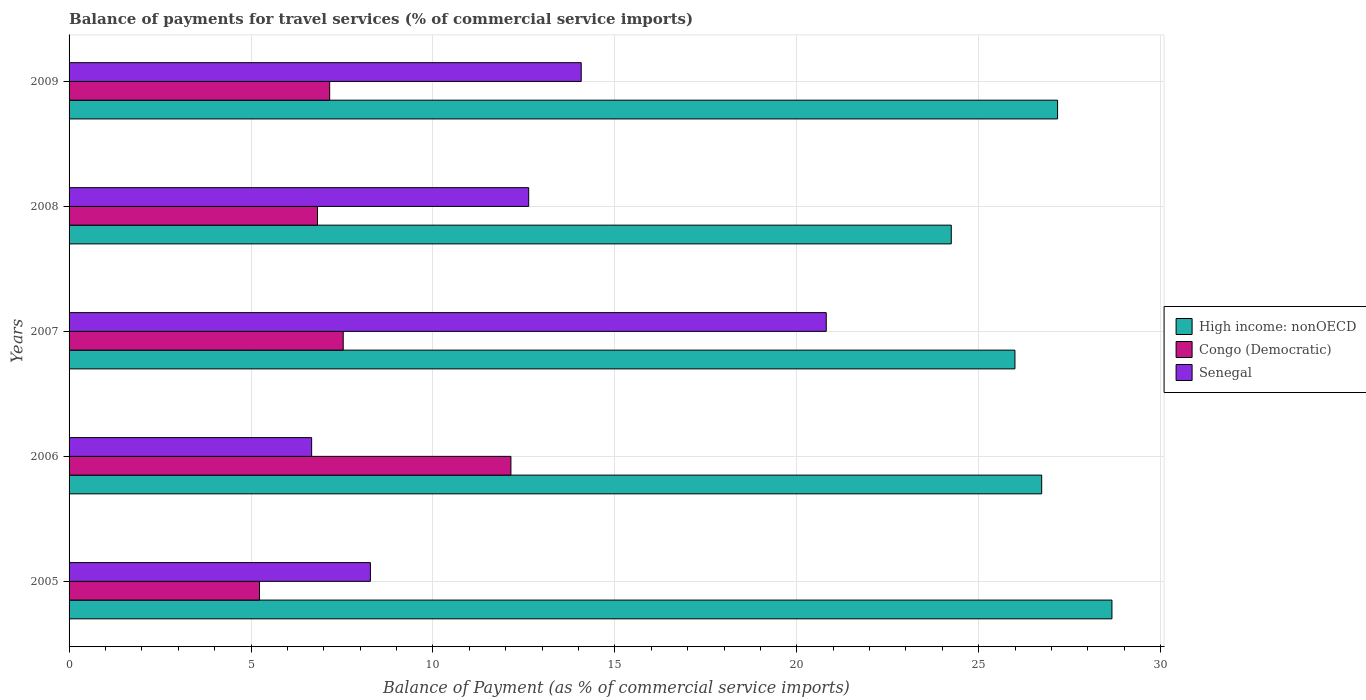How many groups of bars are there?
Your answer should be compact. 5. Are the number of bars per tick equal to the number of legend labels?
Give a very brief answer. Yes. Are the number of bars on each tick of the Y-axis equal?
Give a very brief answer. Yes. How many bars are there on the 2nd tick from the bottom?
Keep it short and to the point. 3. What is the balance of payments for travel services in High income: nonOECD in 2006?
Keep it short and to the point. 26.73. Across all years, what is the maximum balance of payments for travel services in High income: nonOECD?
Provide a short and direct response. 28.66. Across all years, what is the minimum balance of payments for travel services in High income: nonOECD?
Your response must be concise. 24.24. What is the total balance of payments for travel services in High income: nonOECD in the graph?
Provide a succinct answer. 132.8. What is the difference between the balance of payments for travel services in Congo (Democratic) in 2005 and that in 2008?
Provide a succinct answer. -1.59. What is the difference between the balance of payments for travel services in Senegal in 2005 and the balance of payments for travel services in High income: nonOECD in 2009?
Provide a short and direct response. -18.89. What is the average balance of payments for travel services in Senegal per year?
Make the answer very short. 12.49. In the year 2007, what is the difference between the balance of payments for travel services in Senegal and balance of payments for travel services in High income: nonOECD?
Offer a very short reply. -5.19. What is the ratio of the balance of payments for travel services in High income: nonOECD in 2007 to that in 2008?
Make the answer very short. 1.07. Is the balance of payments for travel services in Congo (Democratic) in 2006 less than that in 2009?
Provide a short and direct response. No. Is the difference between the balance of payments for travel services in Senegal in 2005 and 2009 greater than the difference between the balance of payments for travel services in High income: nonOECD in 2005 and 2009?
Your answer should be very brief. No. What is the difference between the highest and the second highest balance of payments for travel services in Senegal?
Provide a succinct answer. 6.73. What is the difference between the highest and the lowest balance of payments for travel services in High income: nonOECD?
Give a very brief answer. 4.42. In how many years, is the balance of payments for travel services in Congo (Democratic) greater than the average balance of payments for travel services in Congo (Democratic) taken over all years?
Provide a short and direct response. 1. Is the sum of the balance of payments for travel services in Senegal in 2006 and 2009 greater than the maximum balance of payments for travel services in Congo (Democratic) across all years?
Offer a very short reply. Yes. What does the 2nd bar from the top in 2007 represents?
Make the answer very short. Congo (Democratic). What does the 2nd bar from the bottom in 2006 represents?
Offer a terse response. Congo (Democratic). Is it the case that in every year, the sum of the balance of payments for travel services in High income: nonOECD and balance of payments for travel services in Congo (Democratic) is greater than the balance of payments for travel services in Senegal?
Provide a succinct answer. Yes. How many bars are there?
Make the answer very short. 15. Are all the bars in the graph horizontal?
Offer a terse response. Yes. How many years are there in the graph?
Give a very brief answer. 5. What is the difference between two consecutive major ticks on the X-axis?
Your answer should be compact. 5. Does the graph contain any zero values?
Your answer should be very brief. No. Does the graph contain grids?
Make the answer very short. Yes. What is the title of the graph?
Offer a very short reply. Balance of payments for travel services (% of commercial service imports). What is the label or title of the X-axis?
Provide a short and direct response. Balance of Payment (as % of commercial service imports). What is the Balance of Payment (as % of commercial service imports) of High income: nonOECD in 2005?
Keep it short and to the point. 28.66. What is the Balance of Payment (as % of commercial service imports) in Congo (Democratic) in 2005?
Your response must be concise. 5.23. What is the Balance of Payment (as % of commercial service imports) of Senegal in 2005?
Provide a succinct answer. 8.28. What is the Balance of Payment (as % of commercial service imports) of High income: nonOECD in 2006?
Your answer should be compact. 26.73. What is the Balance of Payment (as % of commercial service imports) in Congo (Democratic) in 2006?
Keep it short and to the point. 12.14. What is the Balance of Payment (as % of commercial service imports) in Senegal in 2006?
Offer a very short reply. 6.67. What is the Balance of Payment (as % of commercial service imports) in High income: nonOECD in 2007?
Ensure brevity in your answer.  25.99. What is the Balance of Payment (as % of commercial service imports) in Congo (Democratic) in 2007?
Provide a short and direct response. 7.53. What is the Balance of Payment (as % of commercial service imports) of Senegal in 2007?
Your response must be concise. 20.81. What is the Balance of Payment (as % of commercial service imports) of High income: nonOECD in 2008?
Keep it short and to the point. 24.24. What is the Balance of Payment (as % of commercial service imports) in Congo (Democratic) in 2008?
Offer a very short reply. 6.83. What is the Balance of Payment (as % of commercial service imports) of Senegal in 2008?
Provide a succinct answer. 12.63. What is the Balance of Payment (as % of commercial service imports) in High income: nonOECD in 2009?
Your response must be concise. 27.17. What is the Balance of Payment (as % of commercial service imports) in Congo (Democratic) in 2009?
Your response must be concise. 7.16. What is the Balance of Payment (as % of commercial service imports) of Senegal in 2009?
Provide a succinct answer. 14.07. Across all years, what is the maximum Balance of Payment (as % of commercial service imports) of High income: nonOECD?
Your answer should be very brief. 28.66. Across all years, what is the maximum Balance of Payment (as % of commercial service imports) of Congo (Democratic)?
Make the answer very short. 12.14. Across all years, what is the maximum Balance of Payment (as % of commercial service imports) in Senegal?
Offer a terse response. 20.81. Across all years, what is the minimum Balance of Payment (as % of commercial service imports) of High income: nonOECD?
Make the answer very short. 24.24. Across all years, what is the minimum Balance of Payment (as % of commercial service imports) in Congo (Democratic)?
Make the answer very short. 5.23. Across all years, what is the minimum Balance of Payment (as % of commercial service imports) of Senegal?
Provide a short and direct response. 6.67. What is the total Balance of Payment (as % of commercial service imports) in High income: nonOECD in the graph?
Offer a very short reply. 132.8. What is the total Balance of Payment (as % of commercial service imports) in Congo (Democratic) in the graph?
Make the answer very short. 38.9. What is the total Balance of Payment (as % of commercial service imports) in Senegal in the graph?
Your answer should be very brief. 62.46. What is the difference between the Balance of Payment (as % of commercial service imports) in High income: nonOECD in 2005 and that in 2006?
Offer a terse response. 1.93. What is the difference between the Balance of Payment (as % of commercial service imports) in Congo (Democratic) in 2005 and that in 2006?
Make the answer very short. -6.91. What is the difference between the Balance of Payment (as % of commercial service imports) of Senegal in 2005 and that in 2006?
Provide a short and direct response. 1.62. What is the difference between the Balance of Payment (as % of commercial service imports) of High income: nonOECD in 2005 and that in 2007?
Give a very brief answer. 2.67. What is the difference between the Balance of Payment (as % of commercial service imports) of Congo (Democratic) in 2005 and that in 2007?
Your answer should be very brief. -2.3. What is the difference between the Balance of Payment (as % of commercial service imports) in Senegal in 2005 and that in 2007?
Make the answer very short. -12.53. What is the difference between the Balance of Payment (as % of commercial service imports) of High income: nonOECD in 2005 and that in 2008?
Offer a terse response. 4.42. What is the difference between the Balance of Payment (as % of commercial service imports) of Congo (Democratic) in 2005 and that in 2008?
Make the answer very short. -1.59. What is the difference between the Balance of Payment (as % of commercial service imports) of Senegal in 2005 and that in 2008?
Offer a terse response. -4.35. What is the difference between the Balance of Payment (as % of commercial service imports) of High income: nonOECD in 2005 and that in 2009?
Give a very brief answer. 1.49. What is the difference between the Balance of Payment (as % of commercial service imports) in Congo (Democratic) in 2005 and that in 2009?
Offer a terse response. -1.93. What is the difference between the Balance of Payment (as % of commercial service imports) in Senegal in 2005 and that in 2009?
Your response must be concise. -5.79. What is the difference between the Balance of Payment (as % of commercial service imports) in High income: nonOECD in 2006 and that in 2007?
Keep it short and to the point. 0.74. What is the difference between the Balance of Payment (as % of commercial service imports) of Congo (Democratic) in 2006 and that in 2007?
Keep it short and to the point. 4.61. What is the difference between the Balance of Payment (as % of commercial service imports) of Senegal in 2006 and that in 2007?
Your answer should be compact. -14.14. What is the difference between the Balance of Payment (as % of commercial service imports) of High income: nonOECD in 2006 and that in 2008?
Offer a very short reply. 2.48. What is the difference between the Balance of Payment (as % of commercial service imports) of Congo (Democratic) in 2006 and that in 2008?
Offer a very short reply. 5.32. What is the difference between the Balance of Payment (as % of commercial service imports) of Senegal in 2006 and that in 2008?
Your answer should be compact. -5.97. What is the difference between the Balance of Payment (as % of commercial service imports) in High income: nonOECD in 2006 and that in 2009?
Offer a very short reply. -0.44. What is the difference between the Balance of Payment (as % of commercial service imports) of Congo (Democratic) in 2006 and that in 2009?
Give a very brief answer. 4.98. What is the difference between the Balance of Payment (as % of commercial service imports) in Senegal in 2006 and that in 2009?
Make the answer very short. -7.41. What is the difference between the Balance of Payment (as % of commercial service imports) in High income: nonOECD in 2007 and that in 2008?
Ensure brevity in your answer.  1.75. What is the difference between the Balance of Payment (as % of commercial service imports) in Congo (Democratic) in 2007 and that in 2008?
Your answer should be very brief. 0.71. What is the difference between the Balance of Payment (as % of commercial service imports) in Senegal in 2007 and that in 2008?
Give a very brief answer. 8.18. What is the difference between the Balance of Payment (as % of commercial service imports) in High income: nonOECD in 2007 and that in 2009?
Provide a succinct answer. -1.17. What is the difference between the Balance of Payment (as % of commercial service imports) of Congo (Democratic) in 2007 and that in 2009?
Keep it short and to the point. 0.37. What is the difference between the Balance of Payment (as % of commercial service imports) of Senegal in 2007 and that in 2009?
Offer a very short reply. 6.73. What is the difference between the Balance of Payment (as % of commercial service imports) in High income: nonOECD in 2008 and that in 2009?
Your response must be concise. -2.92. What is the difference between the Balance of Payment (as % of commercial service imports) in Congo (Democratic) in 2008 and that in 2009?
Give a very brief answer. -0.34. What is the difference between the Balance of Payment (as % of commercial service imports) in Senegal in 2008 and that in 2009?
Provide a succinct answer. -1.44. What is the difference between the Balance of Payment (as % of commercial service imports) in High income: nonOECD in 2005 and the Balance of Payment (as % of commercial service imports) in Congo (Democratic) in 2006?
Ensure brevity in your answer.  16.52. What is the difference between the Balance of Payment (as % of commercial service imports) of High income: nonOECD in 2005 and the Balance of Payment (as % of commercial service imports) of Senegal in 2006?
Offer a terse response. 21.99. What is the difference between the Balance of Payment (as % of commercial service imports) in Congo (Democratic) in 2005 and the Balance of Payment (as % of commercial service imports) in Senegal in 2006?
Ensure brevity in your answer.  -1.43. What is the difference between the Balance of Payment (as % of commercial service imports) in High income: nonOECD in 2005 and the Balance of Payment (as % of commercial service imports) in Congo (Democratic) in 2007?
Ensure brevity in your answer.  21.13. What is the difference between the Balance of Payment (as % of commercial service imports) of High income: nonOECD in 2005 and the Balance of Payment (as % of commercial service imports) of Senegal in 2007?
Make the answer very short. 7.85. What is the difference between the Balance of Payment (as % of commercial service imports) of Congo (Democratic) in 2005 and the Balance of Payment (as % of commercial service imports) of Senegal in 2007?
Make the answer very short. -15.58. What is the difference between the Balance of Payment (as % of commercial service imports) of High income: nonOECD in 2005 and the Balance of Payment (as % of commercial service imports) of Congo (Democratic) in 2008?
Keep it short and to the point. 21.83. What is the difference between the Balance of Payment (as % of commercial service imports) in High income: nonOECD in 2005 and the Balance of Payment (as % of commercial service imports) in Senegal in 2008?
Offer a terse response. 16.03. What is the difference between the Balance of Payment (as % of commercial service imports) of Congo (Democratic) in 2005 and the Balance of Payment (as % of commercial service imports) of Senegal in 2008?
Your response must be concise. -7.4. What is the difference between the Balance of Payment (as % of commercial service imports) of High income: nonOECD in 2005 and the Balance of Payment (as % of commercial service imports) of Congo (Democratic) in 2009?
Ensure brevity in your answer.  21.5. What is the difference between the Balance of Payment (as % of commercial service imports) of High income: nonOECD in 2005 and the Balance of Payment (as % of commercial service imports) of Senegal in 2009?
Offer a very short reply. 14.59. What is the difference between the Balance of Payment (as % of commercial service imports) of Congo (Democratic) in 2005 and the Balance of Payment (as % of commercial service imports) of Senegal in 2009?
Provide a short and direct response. -8.84. What is the difference between the Balance of Payment (as % of commercial service imports) in High income: nonOECD in 2006 and the Balance of Payment (as % of commercial service imports) in Congo (Democratic) in 2007?
Your response must be concise. 19.2. What is the difference between the Balance of Payment (as % of commercial service imports) of High income: nonOECD in 2006 and the Balance of Payment (as % of commercial service imports) of Senegal in 2007?
Offer a very short reply. 5.92. What is the difference between the Balance of Payment (as % of commercial service imports) in Congo (Democratic) in 2006 and the Balance of Payment (as % of commercial service imports) in Senegal in 2007?
Keep it short and to the point. -8.67. What is the difference between the Balance of Payment (as % of commercial service imports) in High income: nonOECD in 2006 and the Balance of Payment (as % of commercial service imports) in Congo (Democratic) in 2008?
Make the answer very short. 19.9. What is the difference between the Balance of Payment (as % of commercial service imports) in High income: nonOECD in 2006 and the Balance of Payment (as % of commercial service imports) in Senegal in 2008?
Your response must be concise. 14.1. What is the difference between the Balance of Payment (as % of commercial service imports) in Congo (Democratic) in 2006 and the Balance of Payment (as % of commercial service imports) in Senegal in 2008?
Your response must be concise. -0.49. What is the difference between the Balance of Payment (as % of commercial service imports) of High income: nonOECD in 2006 and the Balance of Payment (as % of commercial service imports) of Congo (Democratic) in 2009?
Provide a succinct answer. 19.57. What is the difference between the Balance of Payment (as % of commercial service imports) in High income: nonOECD in 2006 and the Balance of Payment (as % of commercial service imports) in Senegal in 2009?
Offer a terse response. 12.65. What is the difference between the Balance of Payment (as % of commercial service imports) of Congo (Democratic) in 2006 and the Balance of Payment (as % of commercial service imports) of Senegal in 2009?
Offer a terse response. -1.93. What is the difference between the Balance of Payment (as % of commercial service imports) in High income: nonOECD in 2007 and the Balance of Payment (as % of commercial service imports) in Congo (Democratic) in 2008?
Make the answer very short. 19.17. What is the difference between the Balance of Payment (as % of commercial service imports) in High income: nonOECD in 2007 and the Balance of Payment (as % of commercial service imports) in Senegal in 2008?
Provide a short and direct response. 13.36. What is the difference between the Balance of Payment (as % of commercial service imports) in Congo (Democratic) in 2007 and the Balance of Payment (as % of commercial service imports) in Senegal in 2008?
Offer a terse response. -5.1. What is the difference between the Balance of Payment (as % of commercial service imports) of High income: nonOECD in 2007 and the Balance of Payment (as % of commercial service imports) of Congo (Democratic) in 2009?
Ensure brevity in your answer.  18.83. What is the difference between the Balance of Payment (as % of commercial service imports) of High income: nonOECD in 2007 and the Balance of Payment (as % of commercial service imports) of Senegal in 2009?
Your response must be concise. 11.92. What is the difference between the Balance of Payment (as % of commercial service imports) in Congo (Democratic) in 2007 and the Balance of Payment (as % of commercial service imports) in Senegal in 2009?
Keep it short and to the point. -6.54. What is the difference between the Balance of Payment (as % of commercial service imports) of High income: nonOECD in 2008 and the Balance of Payment (as % of commercial service imports) of Congo (Democratic) in 2009?
Keep it short and to the point. 17.08. What is the difference between the Balance of Payment (as % of commercial service imports) in High income: nonOECD in 2008 and the Balance of Payment (as % of commercial service imports) in Senegal in 2009?
Your answer should be very brief. 10.17. What is the difference between the Balance of Payment (as % of commercial service imports) in Congo (Democratic) in 2008 and the Balance of Payment (as % of commercial service imports) in Senegal in 2009?
Your answer should be compact. -7.25. What is the average Balance of Payment (as % of commercial service imports) of High income: nonOECD per year?
Make the answer very short. 26.56. What is the average Balance of Payment (as % of commercial service imports) of Congo (Democratic) per year?
Offer a terse response. 7.78. What is the average Balance of Payment (as % of commercial service imports) of Senegal per year?
Your response must be concise. 12.49. In the year 2005, what is the difference between the Balance of Payment (as % of commercial service imports) in High income: nonOECD and Balance of Payment (as % of commercial service imports) in Congo (Democratic)?
Provide a short and direct response. 23.43. In the year 2005, what is the difference between the Balance of Payment (as % of commercial service imports) of High income: nonOECD and Balance of Payment (as % of commercial service imports) of Senegal?
Provide a succinct answer. 20.38. In the year 2005, what is the difference between the Balance of Payment (as % of commercial service imports) of Congo (Democratic) and Balance of Payment (as % of commercial service imports) of Senegal?
Give a very brief answer. -3.05. In the year 2006, what is the difference between the Balance of Payment (as % of commercial service imports) of High income: nonOECD and Balance of Payment (as % of commercial service imports) of Congo (Democratic)?
Offer a terse response. 14.59. In the year 2006, what is the difference between the Balance of Payment (as % of commercial service imports) in High income: nonOECD and Balance of Payment (as % of commercial service imports) in Senegal?
Keep it short and to the point. 20.06. In the year 2006, what is the difference between the Balance of Payment (as % of commercial service imports) in Congo (Democratic) and Balance of Payment (as % of commercial service imports) in Senegal?
Your answer should be compact. 5.48. In the year 2007, what is the difference between the Balance of Payment (as % of commercial service imports) in High income: nonOECD and Balance of Payment (as % of commercial service imports) in Congo (Democratic)?
Your answer should be very brief. 18.46. In the year 2007, what is the difference between the Balance of Payment (as % of commercial service imports) in High income: nonOECD and Balance of Payment (as % of commercial service imports) in Senegal?
Your answer should be very brief. 5.19. In the year 2007, what is the difference between the Balance of Payment (as % of commercial service imports) in Congo (Democratic) and Balance of Payment (as % of commercial service imports) in Senegal?
Make the answer very short. -13.27. In the year 2008, what is the difference between the Balance of Payment (as % of commercial service imports) of High income: nonOECD and Balance of Payment (as % of commercial service imports) of Congo (Democratic)?
Your answer should be compact. 17.42. In the year 2008, what is the difference between the Balance of Payment (as % of commercial service imports) in High income: nonOECD and Balance of Payment (as % of commercial service imports) in Senegal?
Ensure brevity in your answer.  11.61. In the year 2008, what is the difference between the Balance of Payment (as % of commercial service imports) of Congo (Democratic) and Balance of Payment (as % of commercial service imports) of Senegal?
Give a very brief answer. -5.8. In the year 2009, what is the difference between the Balance of Payment (as % of commercial service imports) in High income: nonOECD and Balance of Payment (as % of commercial service imports) in Congo (Democratic)?
Make the answer very short. 20. In the year 2009, what is the difference between the Balance of Payment (as % of commercial service imports) in High income: nonOECD and Balance of Payment (as % of commercial service imports) in Senegal?
Keep it short and to the point. 13.09. In the year 2009, what is the difference between the Balance of Payment (as % of commercial service imports) in Congo (Democratic) and Balance of Payment (as % of commercial service imports) in Senegal?
Offer a terse response. -6.91. What is the ratio of the Balance of Payment (as % of commercial service imports) of High income: nonOECD in 2005 to that in 2006?
Provide a short and direct response. 1.07. What is the ratio of the Balance of Payment (as % of commercial service imports) in Congo (Democratic) in 2005 to that in 2006?
Give a very brief answer. 0.43. What is the ratio of the Balance of Payment (as % of commercial service imports) in Senegal in 2005 to that in 2006?
Make the answer very short. 1.24. What is the ratio of the Balance of Payment (as % of commercial service imports) in High income: nonOECD in 2005 to that in 2007?
Your response must be concise. 1.1. What is the ratio of the Balance of Payment (as % of commercial service imports) of Congo (Democratic) in 2005 to that in 2007?
Keep it short and to the point. 0.69. What is the ratio of the Balance of Payment (as % of commercial service imports) of Senegal in 2005 to that in 2007?
Ensure brevity in your answer.  0.4. What is the ratio of the Balance of Payment (as % of commercial service imports) in High income: nonOECD in 2005 to that in 2008?
Offer a very short reply. 1.18. What is the ratio of the Balance of Payment (as % of commercial service imports) in Congo (Democratic) in 2005 to that in 2008?
Your answer should be compact. 0.77. What is the ratio of the Balance of Payment (as % of commercial service imports) of Senegal in 2005 to that in 2008?
Your answer should be compact. 0.66. What is the ratio of the Balance of Payment (as % of commercial service imports) of High income: nonOECD in 2005 to that in 2009?
Give a very brief answer. 1.05. What is the ratio of the Balance of Payment (as % of commercial service imports) of Congo (Democratic) in 2005 to that in 2009?
Ensure brevity in your answer.  0.73. What is the ratio of the Balance of Payment (as % of commercial service imports) of Senegal in 2005 to that in 2009?
Give a very brief answer. 0.59. What is the ratio of the Balance of Payment (as % of commercial service imports) in High income: nonOECD in 2006 to that in 2007?
Your answer should be compact. 1.03. What is the ratio of the Balance of Payment (as % of commercial service imports) of Congo (Democratic) in 2006 to that in 2007?
Offer a very short reply. 1.61. What is the ratio of the Balance of Payment (as % of commercial service imports) in Senegal in 2006 to that in 2007?
Offer a very short reply. 0.32. What is the ratio of the Balance of Payment (as % of commercial service imports) in High income: nonOECD in 2006 to that in 2008?
Offer a very short reply. 1.1. What is the ratio of the Balance of Payment (as % of commercial service imports) in Congo (Democratic) in 2006 to that in 2008?
Offer a very short reply. 1.78. What is the ratio of the Balance of Payment (as % of commercial service imports) of Senegal in 2006 to that in 2008?
Provide a short and direct response. 0.53. What is the ratio of the Balance of Payment (as % of commercial service imports) of High income: nonOECD in 2006 to that in 2009?
Provide a short and direct response. 0.98. What is the ratio of the Balance of Payment (as % of commercial service imports) in Congo (Democratic) in 2006 to that in 2009?
Provide a succinct answer. 1.7. What is the ratio of the Balance of Payment (as % of commercial service imports) of Senegal in 2006 to that in 2009?
Your answer should be very brief. 0.47. What is the ratio of the Balance of Payment (as % of commercial service imports) of High income: nonOECD in 2007 to that in 2008?
Offer a terse response. 1.07. What is the ratio of the Balance of Payment (as % of commercial service imports) of Congo (Democratic) in 2007 to that in 2008?
Provide a short and direct response. 1.1. What is the ratio of the Balance of Payment (as % of commercial service imports) in Senegal in 2007 to that in 2008?
Give a very brief answer. 1.65. What is the ratio of the Balance of Payment (as % of commercial service imports) in High income: nonOECD in 2007 to that in 2009?
Ensure brevity in your answer.  0.96. What is the ratio of the Balance of Payment (as % of commercial service imports) in Congo (Democratic) in 2007 to that in 2009?
Give a very brief answer. 1.05. What is the ratio of the Balance of Payment (as % of commercial service imports) in Senegal in 2007 to that in 2009?
Give a very brief answer. 1.48. What is the ratio of the Balance of Payment (as % of commercial service imports) of High income: nonOECD in 2008 to that in 2009?
Provide a succinct answer. 0.89. What is the ratio of the Balance of Payment (as % of commercial service imports) in Congo (Democratic) in 2008 to that in 2009?
Give a very brief answer. 0.95. What is the ratio of the Balance of Payment (as % of commercial service imports) of Senegal in 2008 to that in 2009?
Give a very brief answer. 0.9. What is the difference between the highest and the second highest Balance of Payment (as % of commercial service imports) of High income: nonOECD?
Your answer should be very brief. 1.49. What is the difference between the highest and the second highest Balance of Payment (as % of commercial service imports) of Congo (Democratic)?
Your response must be concise. 4.61. What is the difference between the highest and the second highest Balance of Payment (as % of commercial service imports) of Senegal?
Offer a very short reply. 6.73. What is the difference between the highest and the lowest Balance of Payment (as % of commercial service imports) of High income: nonOECD?
Your answer should be very brief. 4.42. What is the difference between the highest and the lowest Balance of Payment (as % of commercial service imports) in Congo (Democratic)?
Give a very brief answer. 6.91. What is the difference between the highest and the lowest Balance of Payment (as % of commercial service imports) of Senegal?
Ensure brevity in your answer.  14.14. 